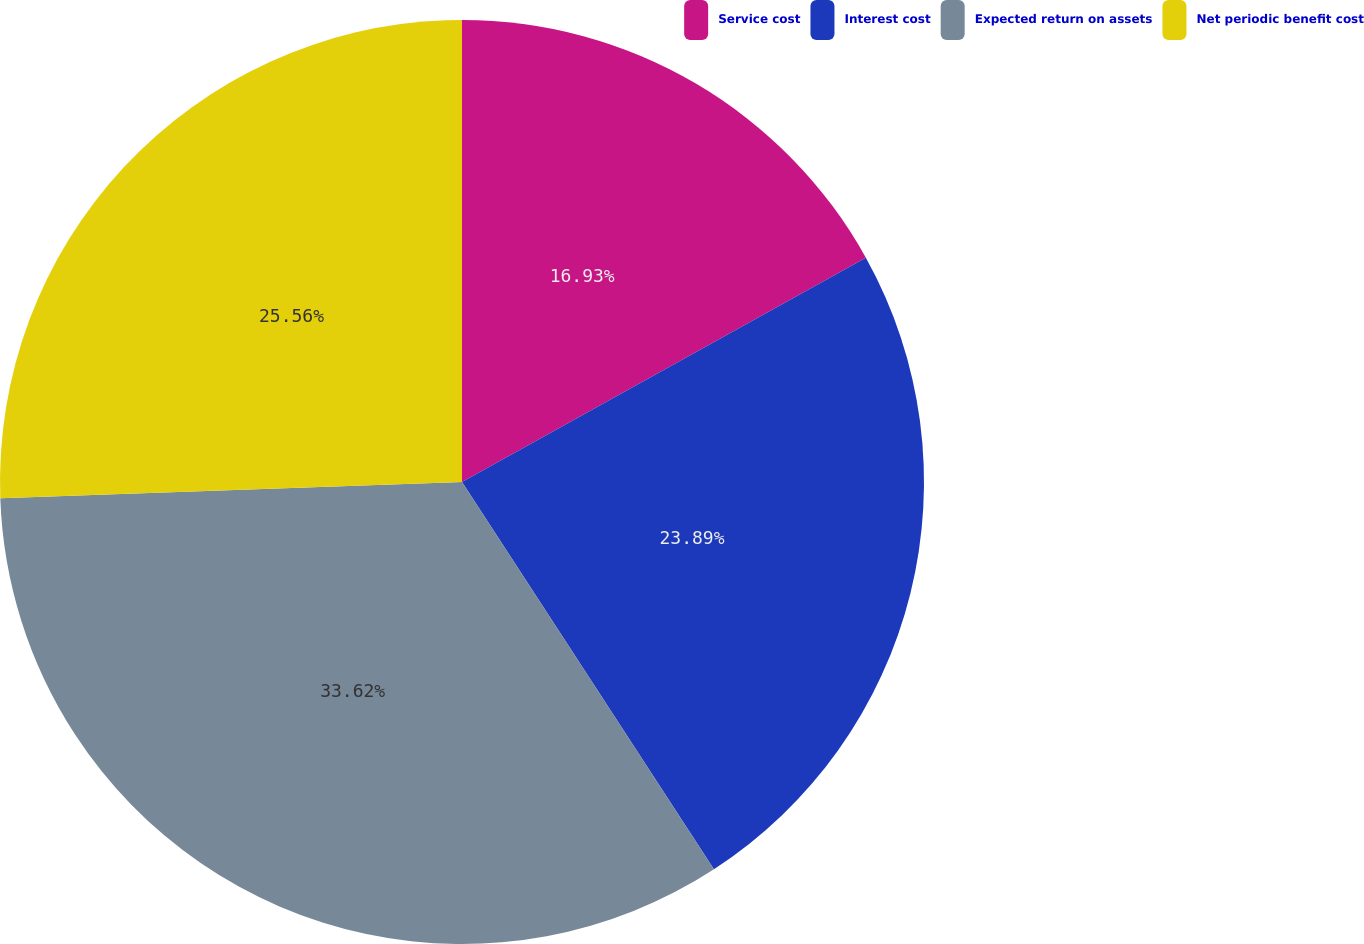Convert chart. <chart><loc_0><loc_0><loc_500><loc_500><pie_chart><fcel>Service cost<fcel>Interest cost<fcel>Expected return on assets<fcel>Net periodic benefit cost<nl><fcel>16.93%<fcel>23.89%<fcel>33.62%<fcel>25.56%<nl></chart> 